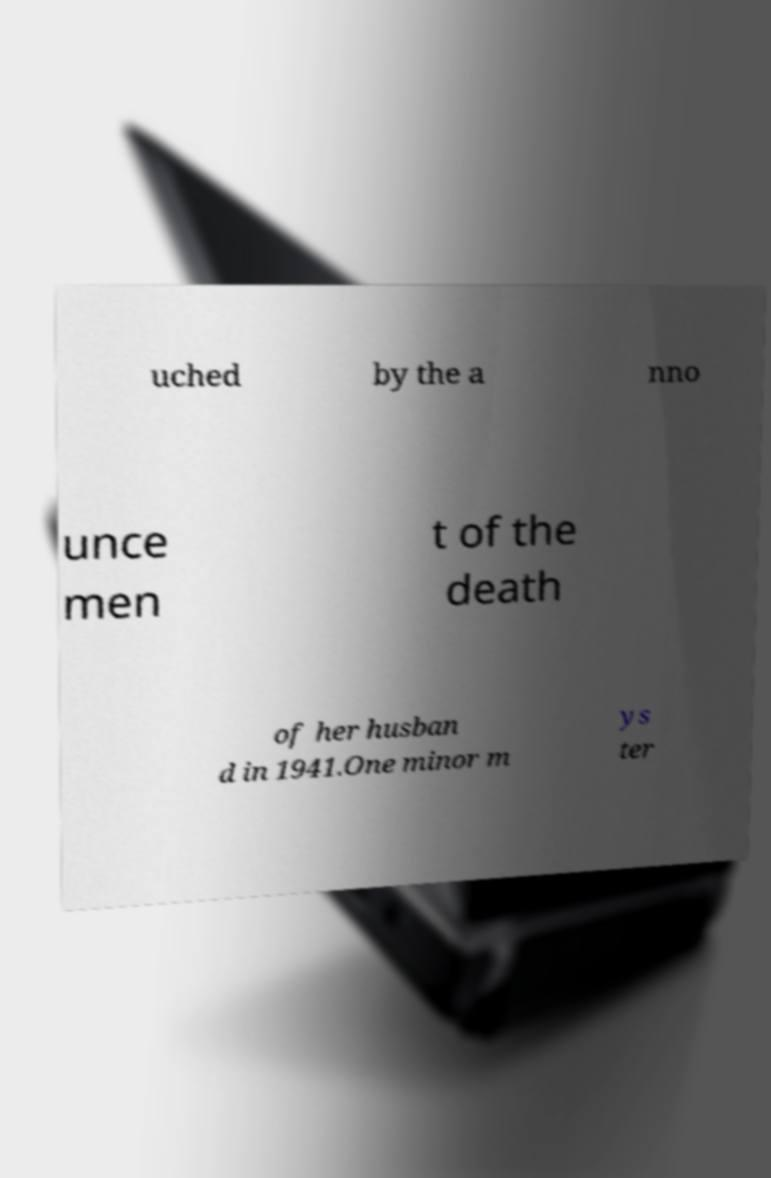What messages or text are displayed in this image? I need them in a readable, typed format. uched by the a nno unce men t of the death of her husban d in 1941.One minor m ys ter 